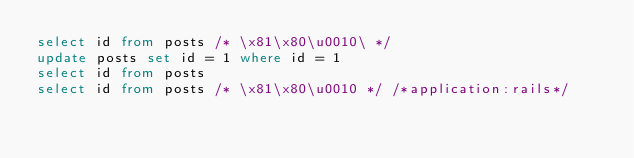<code> <loc_0><loc_0><loc_500><loc_500><_SQL_>select id from posts /* \x81\x80\u0010\ */
update posts set id = 1 where id = 1
select id from posts
select id from posts /* \x81\x80\u0010 */ /*application:rails*/
</code> 